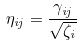<formula> <loc_0><loc_0><loc_500><loc_500>\eta _ { i j } = \frac { \gamma _ { i j } } { \sqrt { \zeta _ { i } } }</formula> 